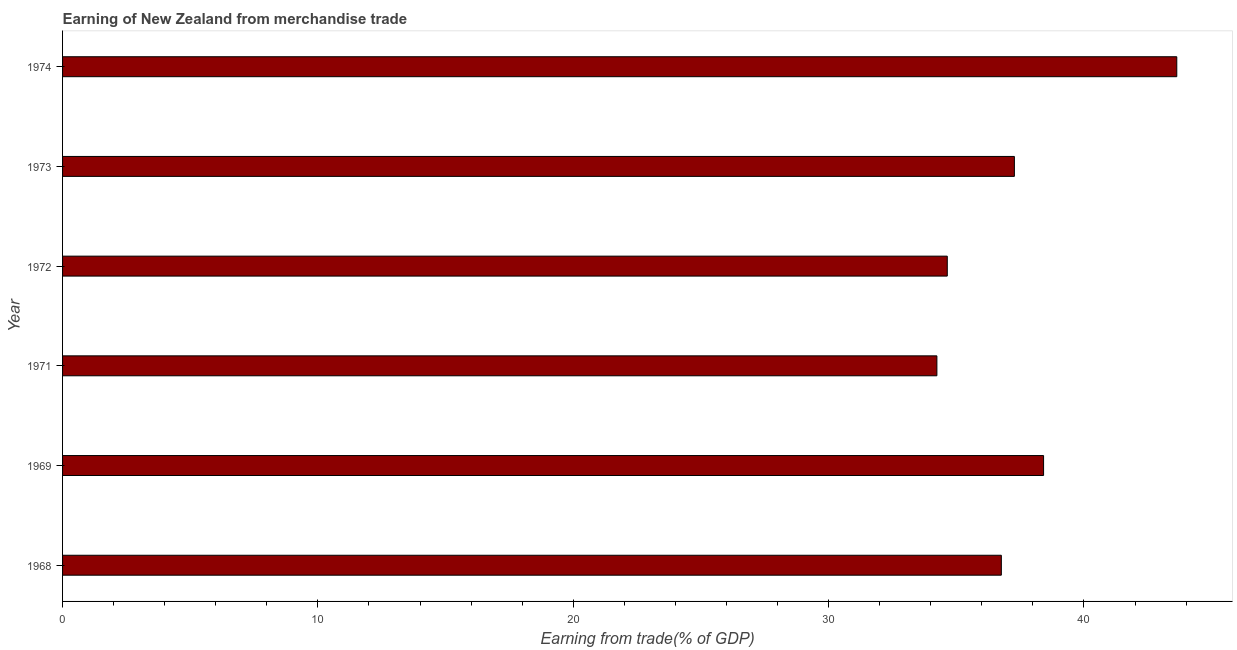Does the graph contain any zero values?
Give a very brief answer. No. What is the title of the graph?
Offer a very short reply. Earning of New Zealand from merchandise trade. What is the label or title of the X-axis?
Keep it short and to the point. Earning from trade(% of GDP). What is the label or title of the Y-axis?
Your answer should be compact. Year. What is the earning from merchandise trade in 1968?
Keep it short and to the point. 36.77. Across all years, what is the maximum earning from merchandise trade?
Make the answer very short. 43.64. Across all years, what is the minimum earning from merchandise trade?
Keep it short and to the point. 34.24. In which year was the earning from merchandise trade maximum?
Ensure brevity in your answer.  1974. In which year was the earning from merchandise trade minimum?
Provide a short and direct response. 1971. What is the sum of the earning from merchandise trade?
Offer a very short reply. 224.99. What is the difference between the earning from merchandise trade in 1969 and 1971?
Provide a succinct answer. 4.18. What is the average earning from merchandise trade per year?
Your response must be concise. 37.5. What is the median earning from merchandise trade?
Your answer should be very brief. 37.02. What is the ratio of the earning from merchandise trade in 1971 to that in 1974?
Provide a succinct answer. 0.79. Is the earning from merchandise trade in 1971 less than that in 1974?
Provide a short and direct response. Yes. What is the difference between the highest and the second highest earning from merchandise trade?
Make the answer very short. 5.22. What is the difference between the highest and the lowest earning from merchandise trade?
Give a very brief answer. 9.39. How many bars are there?
Make the answer very short. 6. Are all the bars in the graph horizontal?
Offer a very short reply. Yes. How many years are there in the graph?
Give a very brief answer. 6. What is the Earning from trade(% of GDP) in 1968?
Your answer should be very brief. 36.77. What is the Earning from trade(% of GDP) in 1969?
Your response must be concise. 38.42. What is the Earning from trade(% of GDP) of 1971?
Your response must be concise. 34.24. What is the Earning from trade(% of GDP) of 1972?
Offer a terse response. 34.65. What is the Earning from trade(% of GDP) of 1973?
Your answer should be compact. 37.28. What is the Earning from trade(% of GDP) in 1974?
Offer a terse response. 43.64. What is the difference between the Earning from trade(% of GDP) in 1968 and 1969?
Provide a short and direct response. -1.65. What is the difference between the Earning from trade(% of GDP) in 1968 and 1971?
Make the answer very short. 2.52. What is the difference between the Earning from trade(% of GDP) in 1968 and 1972?
Keep it short and to the point. 2.12. What is the difference between the Earning from trade(% of GDP) in 1968 and 1973?
Give a very brief answer. -0.51. What is the difference between the Earning from trade(% of GDP) in 1968 and 1974?
Your response must be concise. -6.87. What is the difference between the Earning from trade(% of GDP) in 1969 and 1971?
Provide a short and direct response. 4.18. What is the difference between the Earning from trade(% of GDP) in 1969 and 1972?
Your response must be concise. 3.77. What is the difference between the Earning from trade(% of GDP) in 1969 and 1973?
Ensure brevity in your answer.  1.14. What is the difference between the Earning from trade(% of GDP) in 1969 and 1974?
Keep it short and to the point. -5.22. What is the difference between the Earning from trade(% of GDP) in 1971 and 1972?
Ensure brevity in your answer.  -0.41. What is the difference between the Earning from trade(% of GDP) in 1971 and 1973?
Make the answer very short. -3.03. What is the difference between the Earning from trade(% of GDP) in 1971 and 1974?
Offer a very short reply. -9.39. What is the difference between the Earning from trade(% of GDP) in 1972 and 1973?
Ensure brevity in your answer.  -2.63. What is the difference between the Earning from trade(% of GDP) in 1972 and 1974?
Provide a short and direct response. -8.99. What is the difference between the Earning from trade(% of GDP) in 1973 and 1974?
Provide a succinct answer. -6.36. What is the ratio of the Earning from trade(% of GDP) in 1968 to that in 1969?
Offer a very short reply. 0.96. What is the ratio of the Earning from trade(% of GDP) in 1968 to that in 1971?
Your answer should be compact. 1.07. What is the ratio of the Earning from trade(% of GDP) in 1968 to that in 1972?
Offer a very short reply. 1.06. What is the ratio of the Earning from trade(% of GDP) in 1968 to that in 1973?
Your answer should be compact. 0.99. What is the ratio of the Earning from trade(% of GDP) in 1968 to that in 1974?
Offer a terse response. 0.84. What is the ratio of the Earning from trade(% of GDP) in 1969 to that in 1971?
Offer a terse response. 1.12. What is the ratio of the Earning from trade(% of GDP) in 1969 to that in 1972?
Provide a short and direct response. 1.11. What is the ratio of the Earning from trade(% of GDP) in 1969 to that in 1973?
Give a very brief answer. 1.03. What is the ratio of the Earning from trade(% of GDP) in 1969 to that in 1974?
Provide a succinct answer. 0.88. What is the ratio of the Earning from trade(% of GDP) in 1971 to that in 1973?
Give a very brief answer. 0.92. What is the ratio of the Earning from trade(% of GDP) in 1971 to that in 1974?
Your answer should be very brief. 0.79. What is the ratio of the Earning from trade(% of GDP) in 1972 to that in 1973?
Provide a succinct answer. 0.93. What is the ratio of the Earning from trade(% of GDP) in 1972 to that in 1974?
Give a very brief answer. 0.79. What is the ratio of the Earning from trade(% of GDP) in 1973 to that in 1974?
Provide a succinct answer. 0.85. 